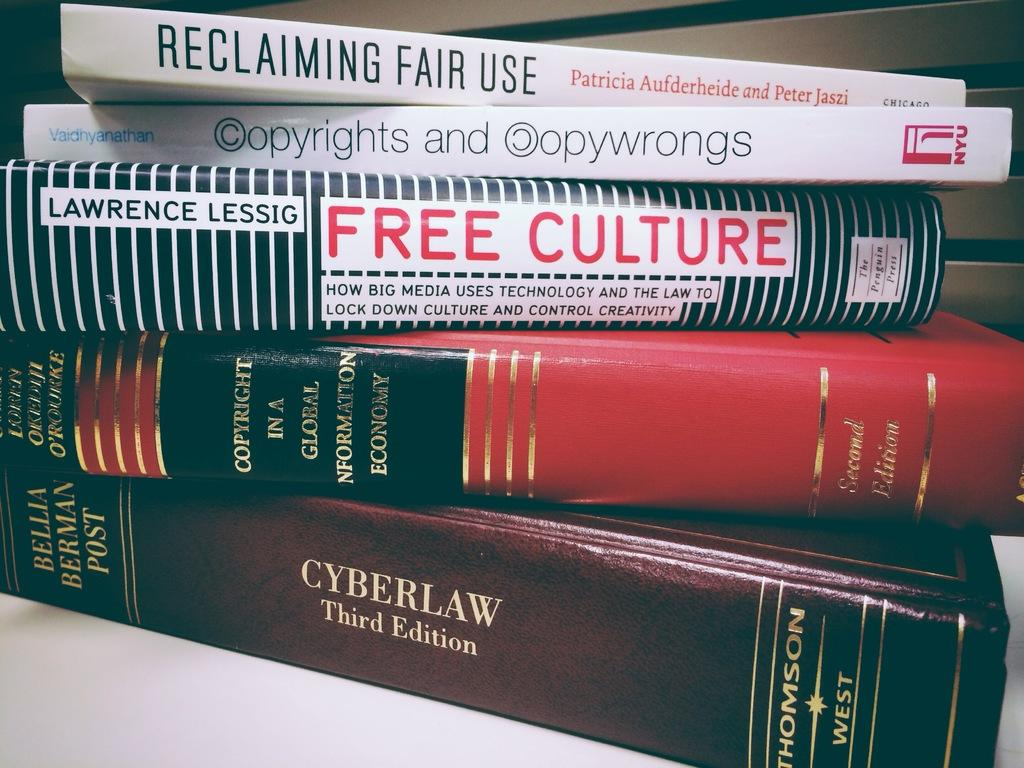<image>
Provide a brief description of the given image. A striped book called Free Culture is in the middle of a stack of books. 